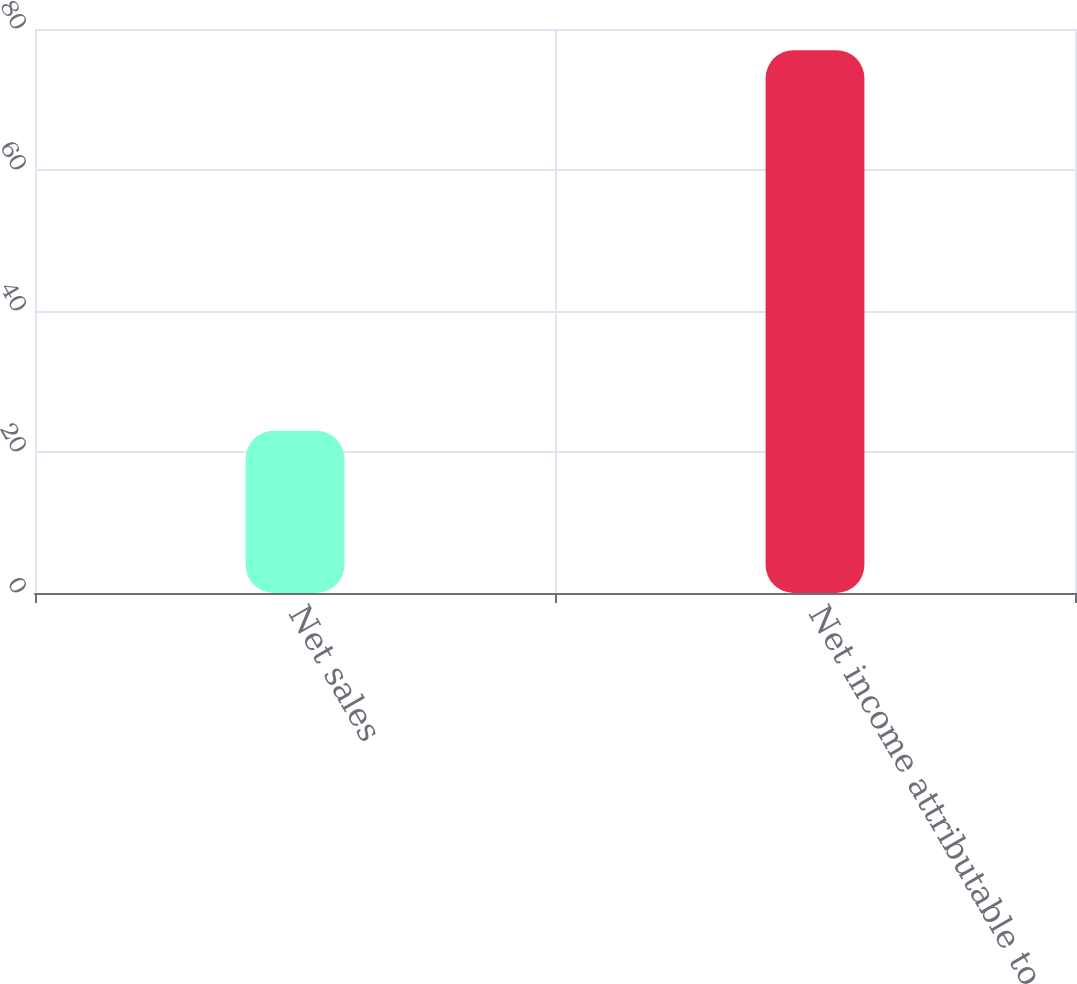<chart> <loc_0><loc_0><loc_500><loc_500><bar_chart><fcel>Net sales<fcel>Net income attributable to<nl><fcel>23<fcel>77<nl></chart> 